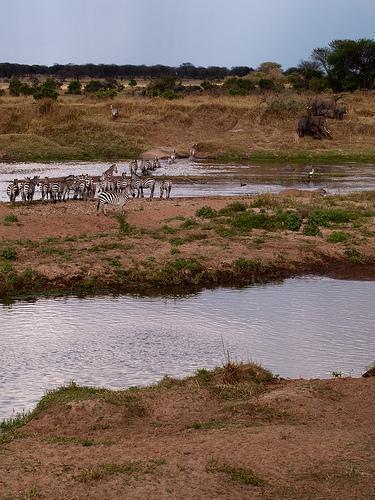How many zebras are not standing by or in the river?
Give a very brief answer. 2. How many zebras are on the other side of the river from the pack?
Give a very brief answer. 3. How many sections of water?
Give a very brief answer. 2. 